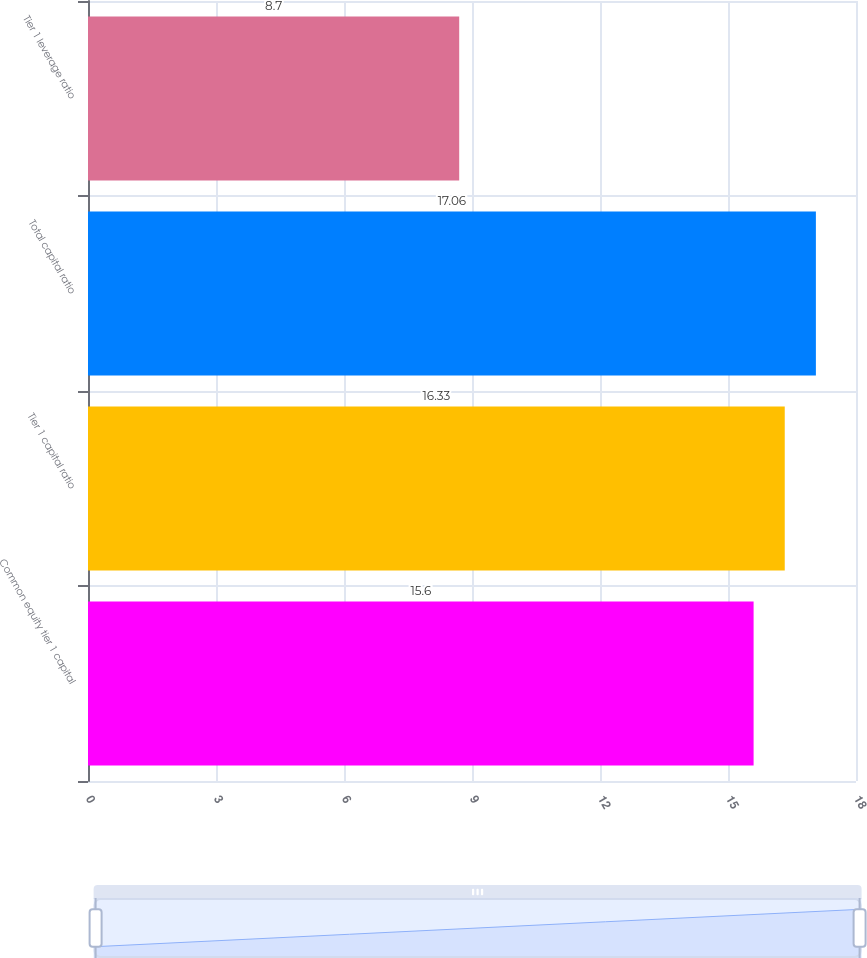<chart> <loc_0><loc_0><loc_500><loc_500><bar_chart><fcel>Common equity tier 1 capital<fcel>Tier 1 capital ratio<fcel>Total capital ratio<fcel>Tier 1 leverage ratio<nl><fcel>15.6<fcel>16.33<fcel>17.06<fcel>8.7<nl></chart> 